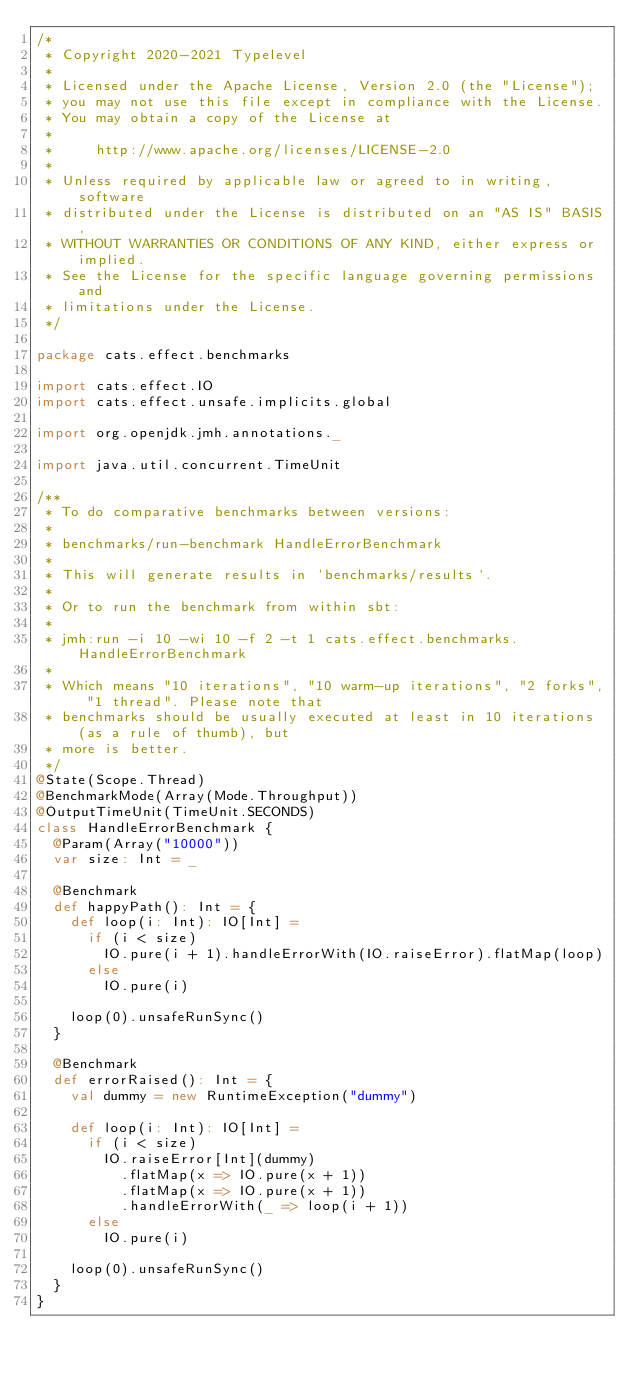Convert code to text. <code><loc_0><loc_0><loc_500><loc_500><_Scala_>/*
 * Copyright 2020-2021 Typelevel
 *
 * Licensed under the Apache License, Version 2.0 (the "License");
 * you may not use this file except in compliance with the License.
 * You may obtain a copy of the License at
 *
 *     http://www.apache.org/licenses/LICENSE-2.0
 *
 * Unless required by applicable law or agreed to in writing, software
 * distributed under the License is distributed on an "AS IS" BASIS,
 * WITHOUT WARRANTIES OR CONDITIONS OF ANY KIND, either express or implied.
 * See the License for the specific language governing permissions and
 * limitations under the License.
 */

package cats.effect.benchmarks

import cats.effect.IO
import cats.effect.unsafe.implicits.global

import org.openjdk.jmh.annotations._

import java.util.concurrent.TimeUnit

/**
 * To do comparative benchmarks between versions:
 *
 * benchmarks/run-benchmark HandleErrorBenchmark
 *
 * This will generate results in `benchmarks/results`.
 *
 * Or to run the benchmark from within sbt:
 *
 * jmh:run -i 10 -wi 10 -f 2 -t 1 cats.effect.benchmarks.HandleErrorBenchmark
 *
 * Which means "10 iterations", "10 warm-up iterations", "2 forks", "1 thread". Please note that
 * benchmarks should be usually executed at least in 10 iterations (as a rule of thumb), but
 * more is better.
 */
@State(Scope.Thread)
@BenchmarkMode(Array(Mode.Throughput))
@OutputTimeUnit(TimeUnit.SECONDS)
class HandleErrorBenchmark {
  @Param(Array("10000"))
  var size: Int = _

  @Benchmark
  def happyPath(): Int = {
    def loop(i: Int): IO[Int] =
      if (i < size)
        IO.pure(i + 1).handleErrorWith(IO.raiseError).flatMap(loop)
      else
        IO.pure(i)

    loop(0).unsafeRunSync()
  }

  @Benchmark
  def errorRaised(): Int = {
    val dummy = new RuntimeException("dummy")

    def loop(i: Int): IO[Int] =
      if (i < size)
        IO.raiseError[Int](dummy)
          .flatMap(x => IO.pure(x + 1))
          .flatMap(x => IO.pure(x + 1))
          .handleErrorWith(_ => loop(i + 1))
      else
        IO.pure(i)

    loop(0).unsafeRunSync()
  }
}
</code> 